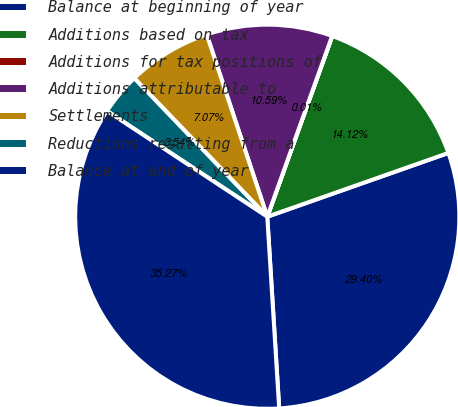Convert chart. <chart><loc_0><loc_0><loc_500><loc_500><pie_chart><fcel>Balance at beginning of year<fcel>Additions based on tax<fcel>Additions for tax positions of<fcel>Additions attributable to<fcel>Settlements<fcel>Reductions resulting from a<fcel>Balance at end of year<nl><fcel>29.4%<fcel>14.12%<fcel>0.01%<fcel>10.59%<fcel>7.07%<fcel>3.54%<fcel>35.27%<nl></chart> 